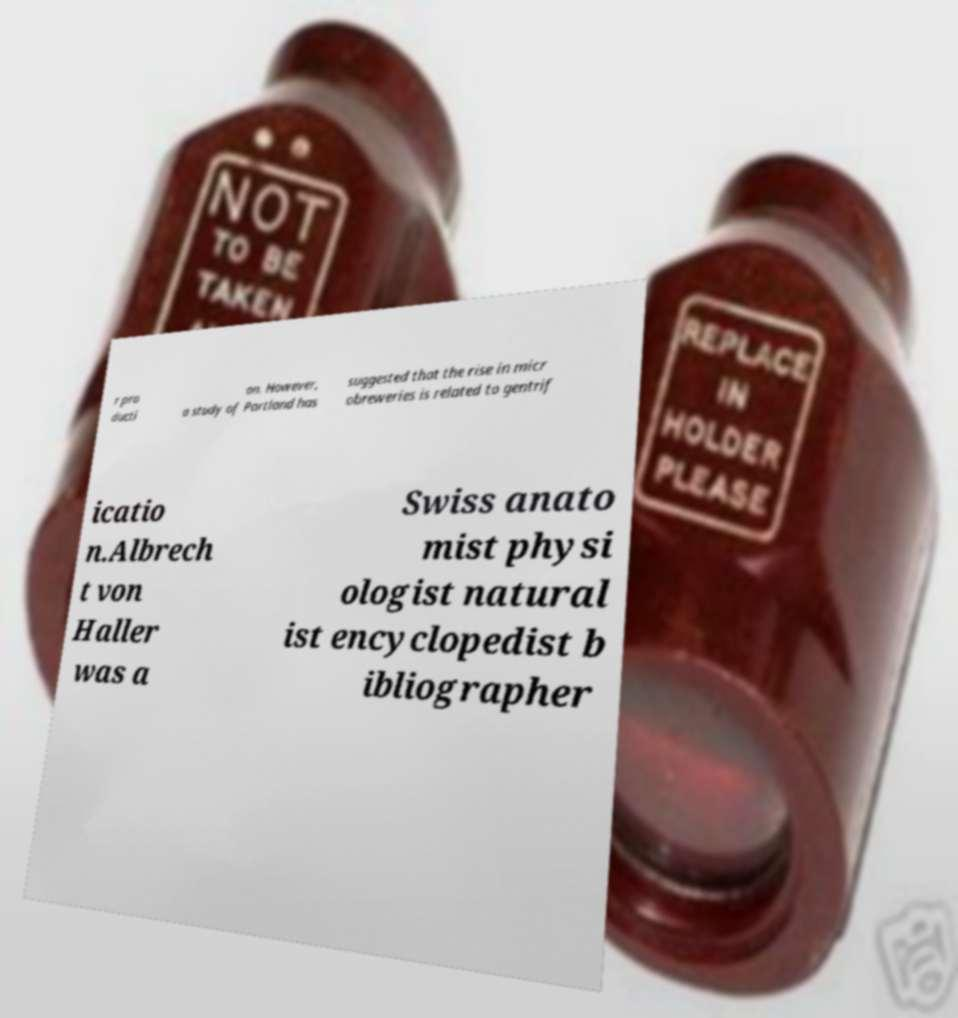Could you extract and type out the text from this image? r pro ducti on. However, a study of Portland has suggested that the rise in micr obreweries is related to gentrif icatio n.Albrech t von Haller was a Swiss anato mist physi ologist natural ist encyclopedist b ibliographer 